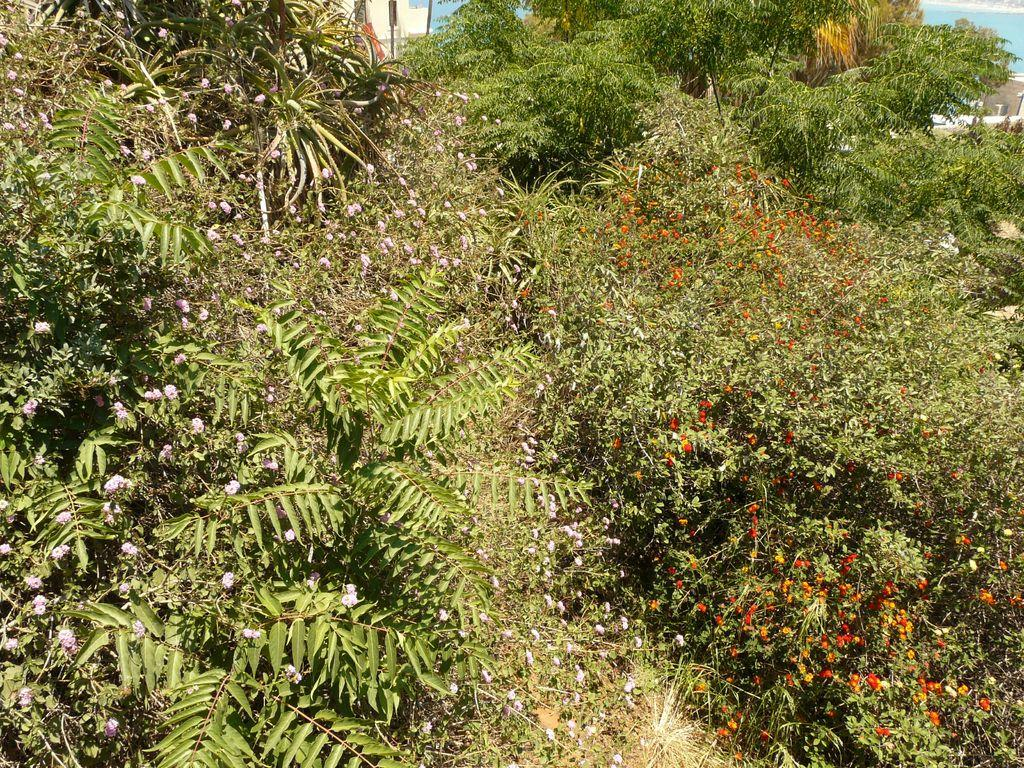What type of vegetation can be seen in the foreground of the image? There is greenery and small flowers in the foreground of the image. What is visible in the background of the image? It appears to be water in the background of the image, along with a wall. How many chairs are placed near the greenery in the image? There are no chairs present in the image. What type of knowledge can be gained from the small flowers in the image? The image does not convey any specific knowledge, and the small flowers are not associated with any knowledge. 